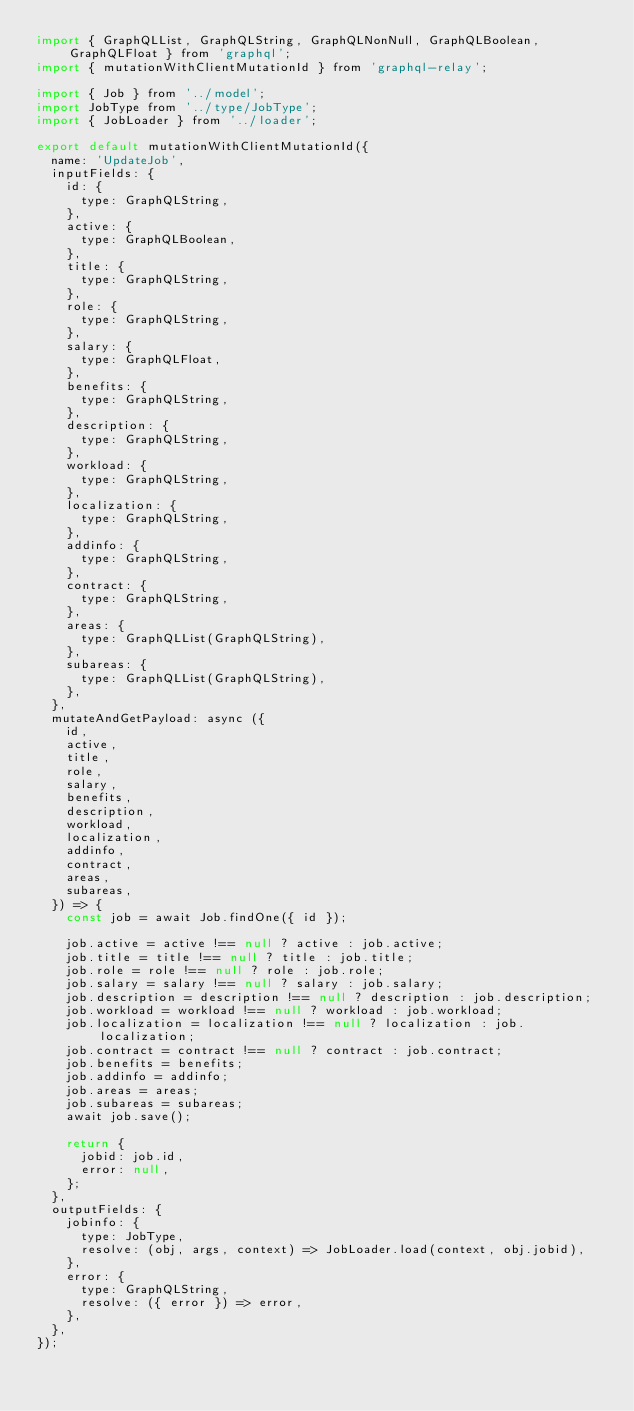Convert code to text. <code><loc_0><loc_0><loc_500><loc_500><_JavaScript_>import { GraphQLList, GraphQLString, GraphQLNonNull, GraphQLBoolean, GraphQLFloat } from 'graphql';
import { mutationWithClientMutationId } from 'graphql-relay';

import { Job } from '../model';
import JobType from '../type/JobType';
import { JobLoader } from '../loader';

export default mutationWithClientMutationId({
  name: 'UpdateJob',
  inputFields: {
    id: {
      type: GraphQLString,
    },
    active: {
      type: GraphQLBoolean,
    },
    title: {
      type: GraphQLString,
    },
    role: {
      type: GraphQLString,
    },
    salary: {
      type: GraphQLFloat,
    },
    benefits: {
      type: GraphQLString,
    },
    description: {
      type: GraphQLString,
    },
    workload: {
      type: GraphQLString,
    },
    localization: {
      type: GraphQLString,
    },
    addinfo: {
      type: GraphQLString,
    },
    contract: {
      type: GraphQLString,
    },
    areas: {
      type: GraphQLList(GraphQLString),
    },
    subareas: {
      type: GraphQLList(GraphQLString),
    },
  },
  mutateAndGetPayload: async ({
    id,
    active,
    title,
    role,
    salary,
    benefits,
    description,
    workload,
    localization,
    addinfo,
    contract,
    areas,
    subareas,
  }) => {
    const job = await Job.findOne({ id });

    job.active = active !== null ? active : job.active;
    job.title = title !== null ? title : job.title;
    job.role = role !== null ? role : job.role;
    job.salary = salary !== null ? salary : job.salary;
    job.description = description !== null ? description : job.description;
    job.workload = workload !== null ? workload : job.workload;
    job.localization = localization !== null ? localization : job.localization;
    job.contract = contract !== null ? contract : job.contract;
    job.benefits = benefits;
    job.addinfo = addinfo;
    job.areas = areas;
    job.subareas = subareas;
    await job.save();

    return {
      jobid: job.id,
      error: null,
    };
  },
  outputFields: {
    jobinfo: {
      type: JobType,
      resolve: (obj, args, context) => JobLoader.load(context, obj.jobid),
    },
    error: {
      type: GraphQLString,
      resolve: ({ error }) => error,
    },
  },
});
</code> 